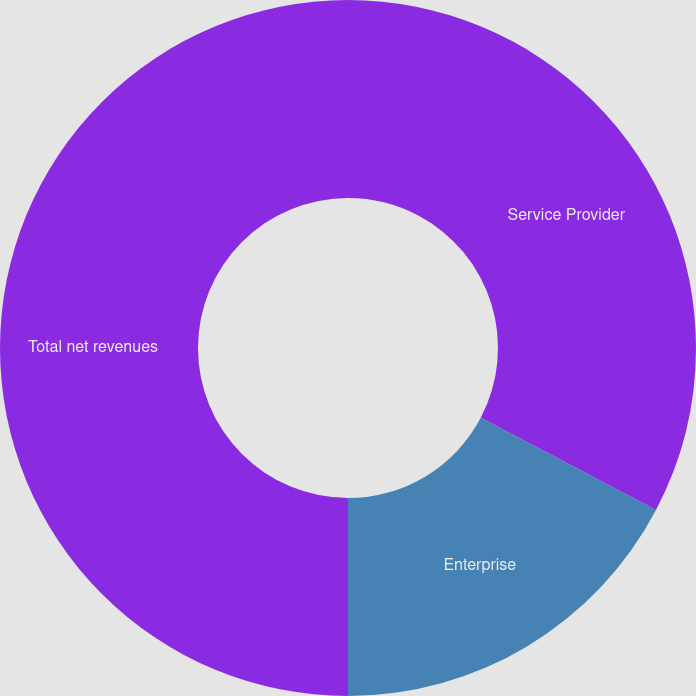Convert chart. <chart><loc_0><loc_0><loc_500><loc_500><pie_chart><fcel>Service Provider<fcel>Enterprise<fcel>Total net revenues<nl><fcel>32.71%<fcel>17.29%<fcel>50.0%<nl></chart> 